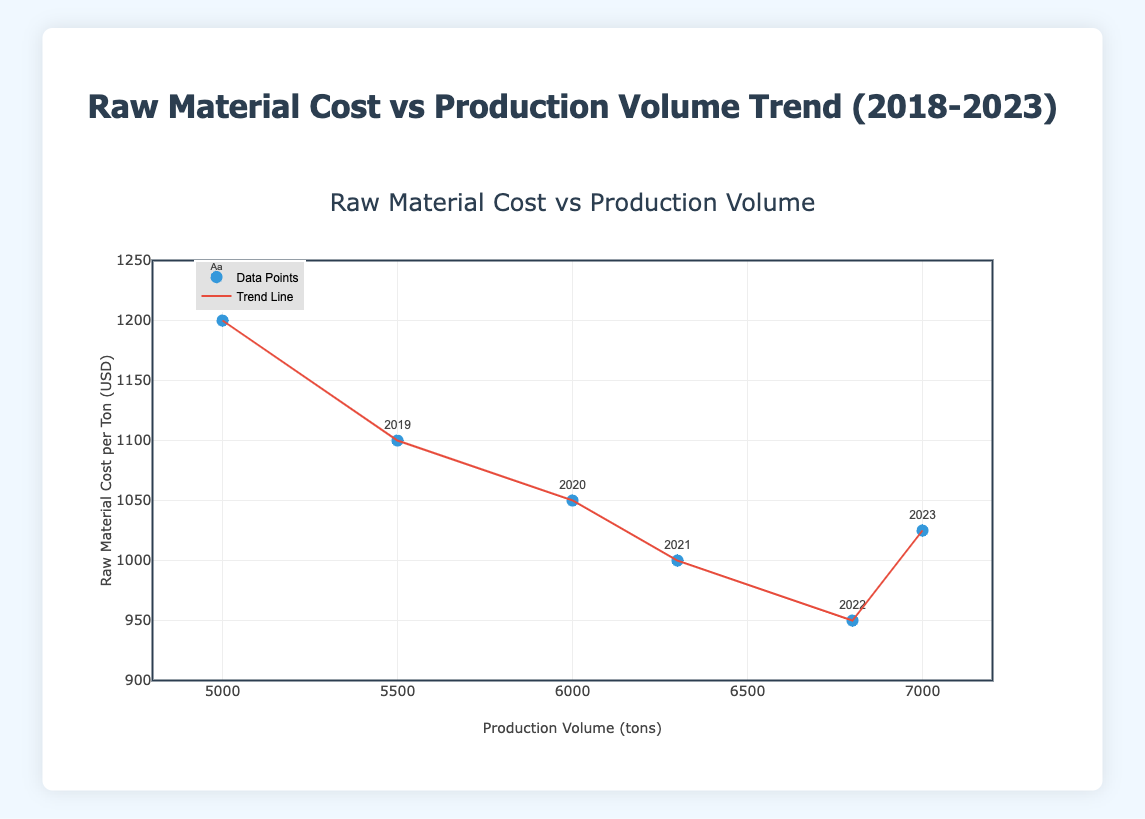What is the title of the figure? The title of the figure is displayed at the top center of the scatter plot with the trend line. It reads, "Raw Material Cost vs Production Volume Trend (2018-2023)."
Answer: Raw Material Cost vs Production Volume Trend (2018-2023) How many data points are there in the plot? By counting the individual markers on the scatter plot, you can see there are 6 data points, each corresponding to a year from 2018 to 2023.
Answer: 6 What is the range of the x-axis in the plot? The x-axis represents production volume measured in tons. The axis range is clearly labeled on the plot, indicating a range from 4800 to 7200 tons.
Answer: 4800 to 7200 Which year has the lowest raw material cost per ton? By examining the data points and their labels on the scatter plot, you can see that the year 2022 has the lowest raw material cost per ton, at 950 USD.
Answer: 2022 Compare the raw material cost per ton between the years 2021 and 2023. Which year had a higher cost? By looking at the data points for the years 2021 and 2023, you can see that the raw material cost per ton in 2021 was 1000 USD, whereas in 2023, it was 1025 USD. Therefore, the cost was higher in 2023.
Answer: 2023 Estimate the average production volume of the years 2018 through 2020. To find the average production volume, add the production volumes for the years 2018, 2019, and 2020 (5000 + 5500 + 6000) and divide by 3. The calculation is (5000 + 5500 + 6000) / 3 = 5500 tons.
Answer: 5500 tons Is the trend line indicating a positive or negative relationship between raw material cost and production volume? The trend line on the scatter plot is sloping downwards from left to right, indicating a negative relationship between raw material cost per ton and production volume.
Answer: Negative Describe how the raw material cost changed from 2018 to 2023. Observing the data points from 2018 (1200 USD per ton) to 2023 (1025 USD per ton), the raw material cost per ton generally decreased over this period, despite a slight increase in 2023 compared to the previous year.
Answer: Decreased What is the raw material cost per ton for the year with the highest production volume in the plot? The highest production volume in the plot is 7000 tons, which corresponds to the year 2023. The raw material cost per ton for that year is 1025 USD.
Answer: 1025 USD 